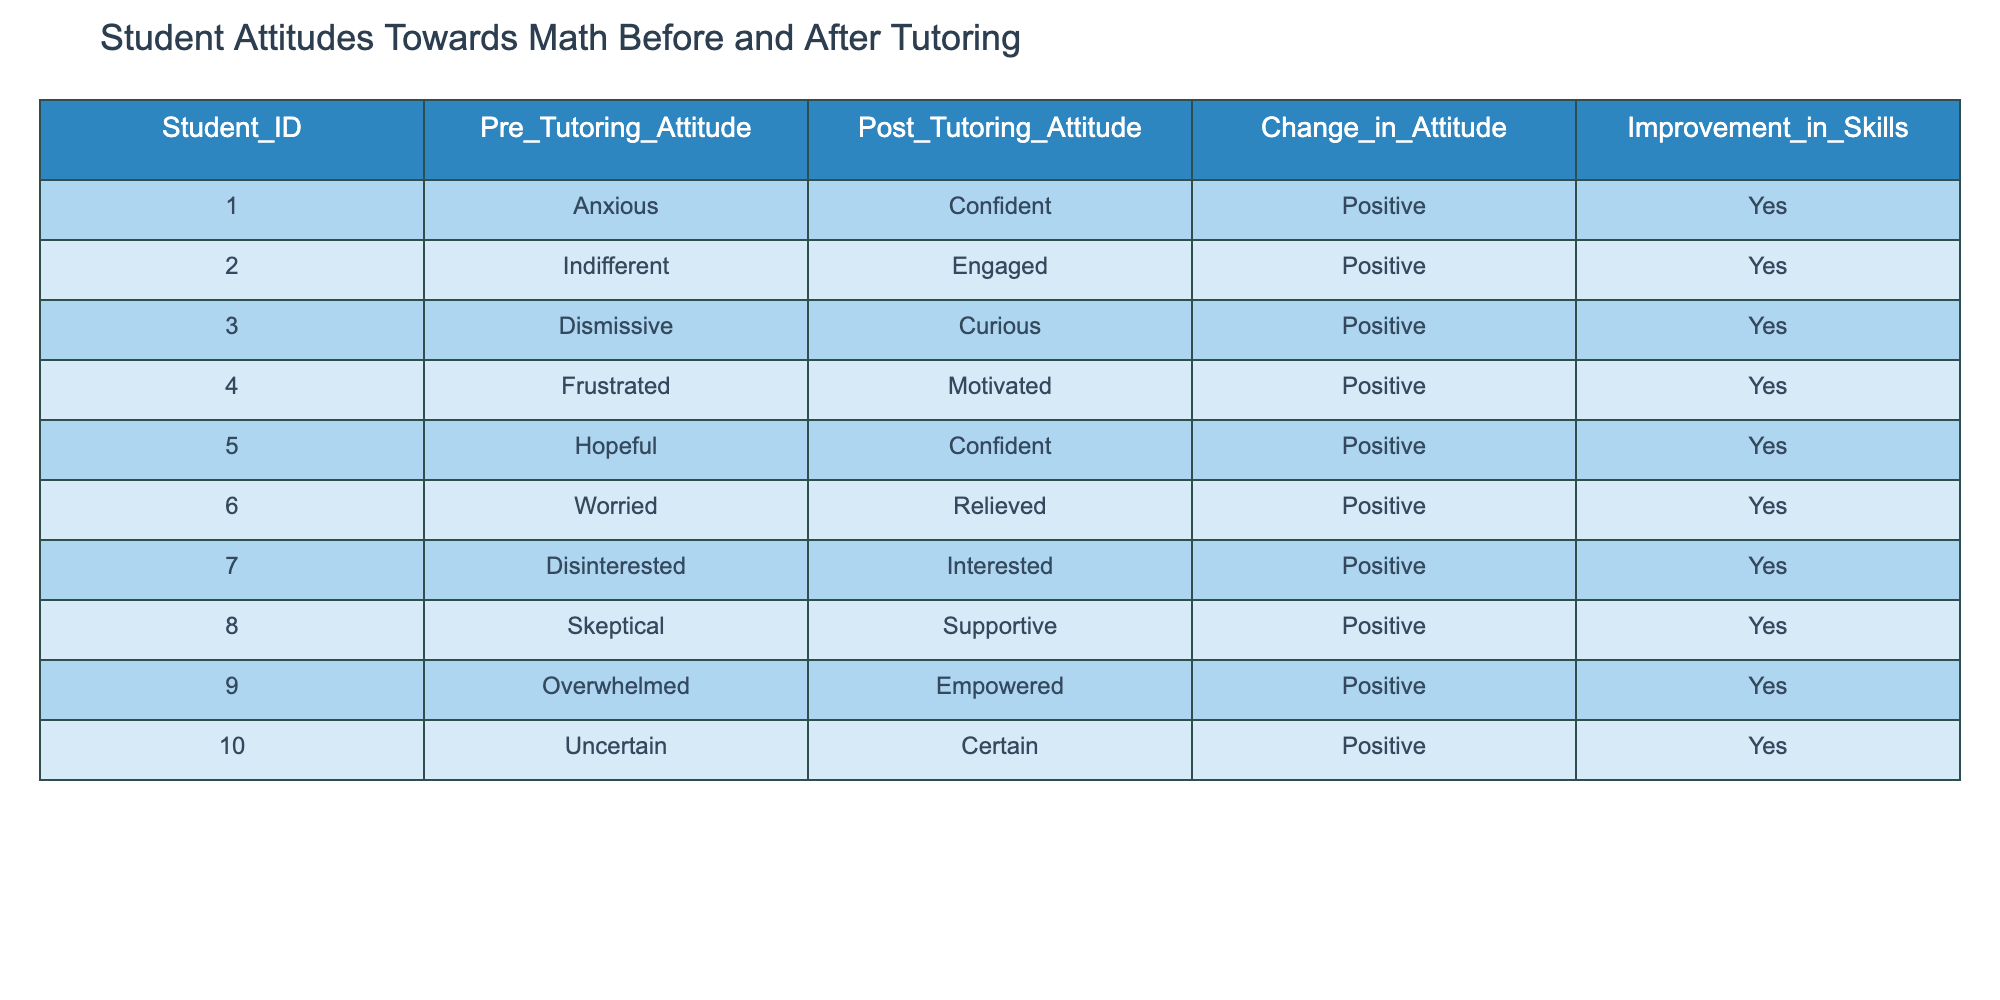What were the attitudes of student ID 5 before tutoring? Student ID 5 had a pre-tutoring attitude of "Hopeful" according to the table.
Answer: Hopeful How many students reported a positive change in their attitude after tutoring? All 10 students in the table indicated a positive change in their attitude after tutoring by showing a shift from their pre-tutoring attitudes to more confident or engaged post-tutoring attitudes.
Answer: 10 What is the post-tutoring attitude of the student with ID 3? The student with ID 3 showed a post-tutoring attitude of "Curious" after the tutoring intervention.
Answer: Curious How many students were either anxious or overwhelmed before tutoring? Students 1 (Anxious) and 9 (Overwhelmed) represent two separate instances of pre-tutoring attitudes of anxiety or feeling overwhelmed, totaling 2 students.
Answer: 2 What is the average change in attitude among the students? Each student in the table indicates a positive change in attitude after tutoring; therefore, the average change is positive since all responses reflect improvement.
Answer: Positive Do any students remain indifferent about math after tutoring? No, all the students had a shift from their pre-tutoring attitudes to more engaged post-tutoring attitudes, indicating that none remained indifferent afterwards.
Answer: No How many total students felt confident after tutoring? Students 1, 5, and 10 reported being "Confident" post-tutoring. This gives a total of 3 students who felt confident after tutoring.
Answer: 3 What was the overall percentage of students who improved their skills? Since all 10 students are marked as having improved their skills, the percentage of students who improved is (10/10) * 100 = 100%.
Answer: 100% 